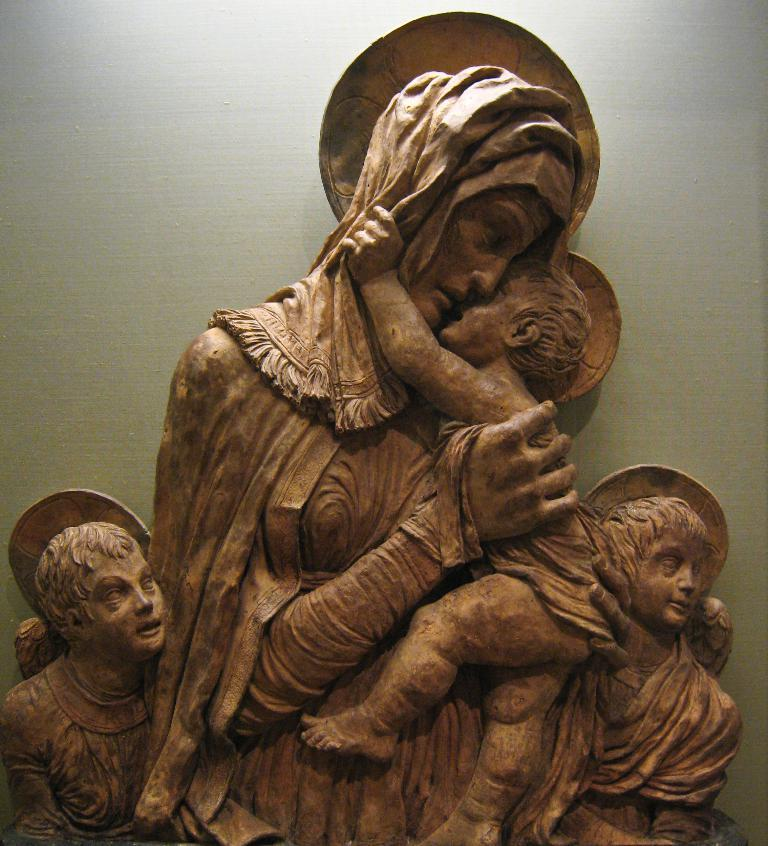What is the main subject in the image? There is a sculpture in the image. Can you describe the setting or environment in which the sculpture is located? There is a wall visible in the image, specifically on the backside of the sculpture. What type of furniture is depicted in the image? There is no furniture present in the image; it features a sculpture and a wall. What news headline is visible on the sculpture in the image? There is no news headline present on the sculpture in the image. 